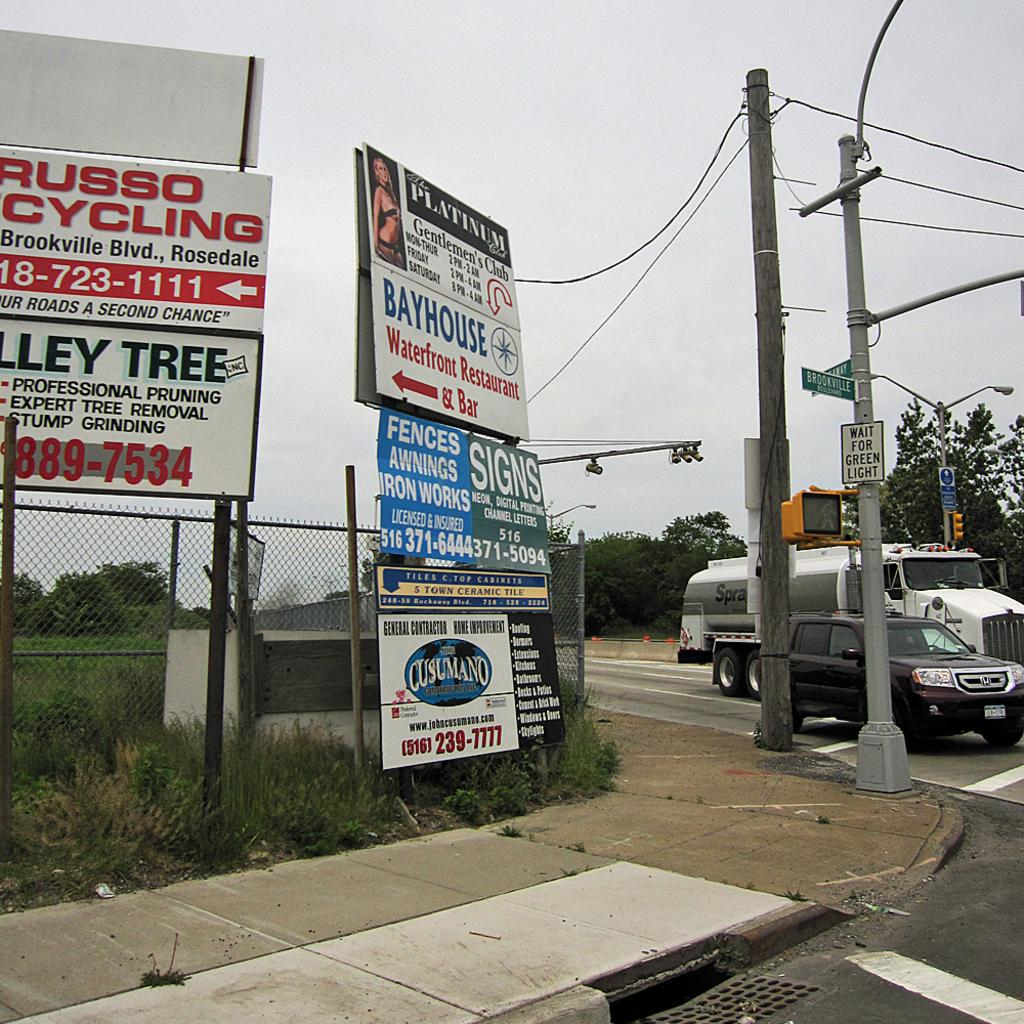What can be seen on the sign boards in the image? The information on the sign boards is not visible in the image. What type of vegetation is present in the image? There is grass and trees visible in the image. What type of barrier is present in the image? There is fencing in the image. What type of structures can be seen in the image? There are poles and vehicles visible in the image. What type of surface is present in the image? There is a road in the image. What is visible in the background of the image? The sky is visible in the background of the image. Can you tell me how many men are joining the hospital in the image? There are no men or hospitals present in the image. What type of creature is shown interacting with the vehicles on the road in the image? There are no creatures shown interacting with the vehicles on the road in the image; only vehicles, sign boards, grass, trees, fencing, poles, and the sky are present. 